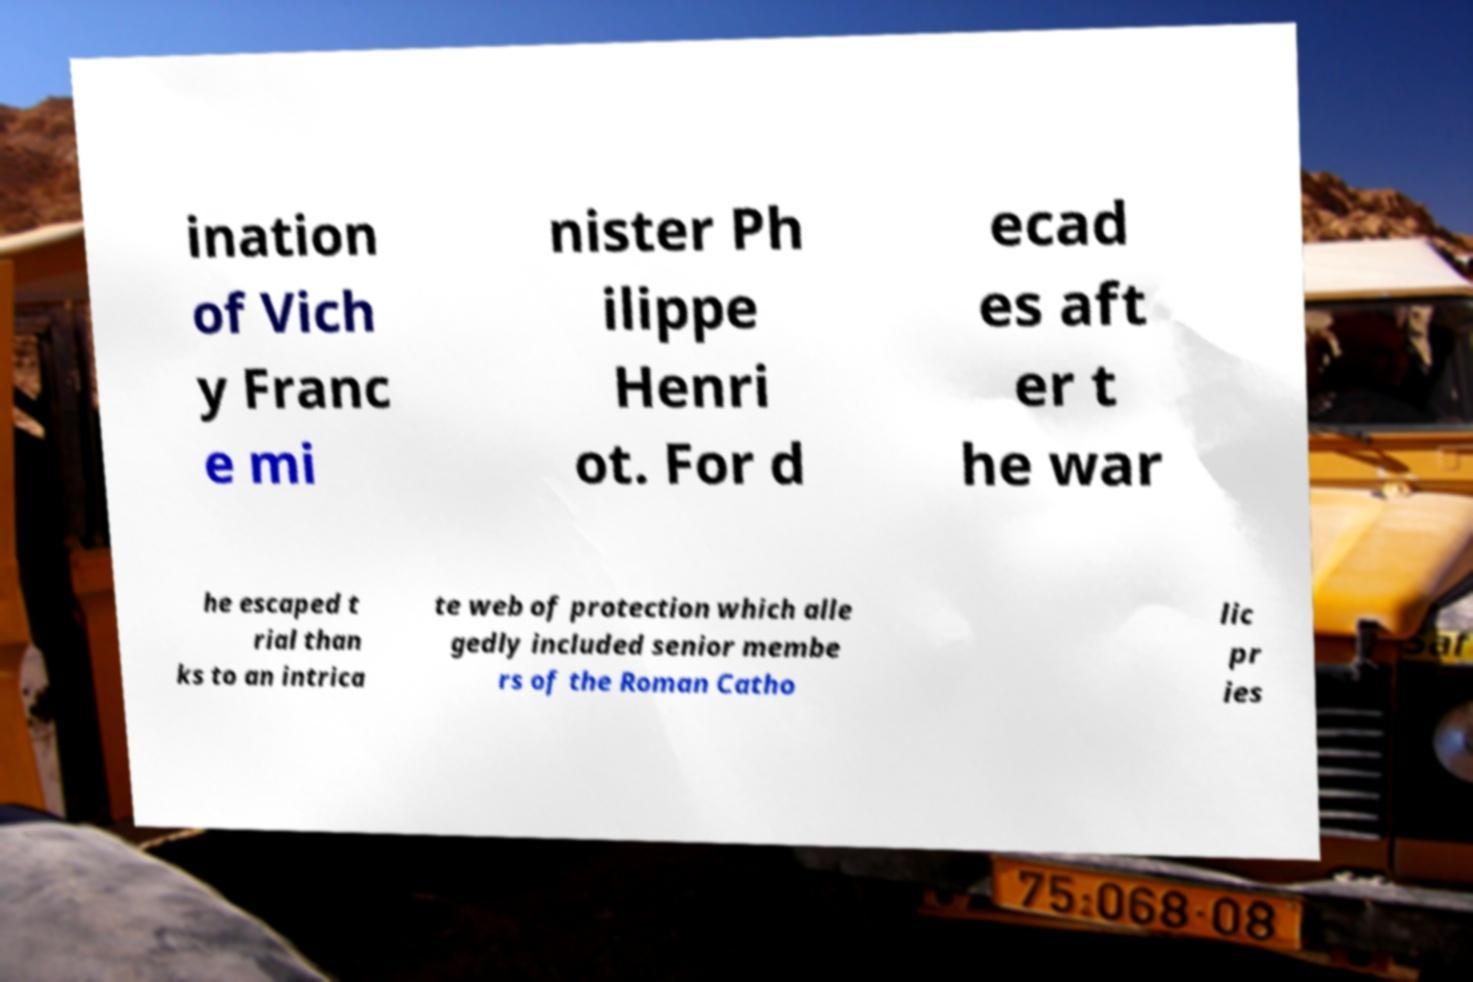Could you extract and type out the text from this image? ination of Vich y Franc e mi nister Ph ilippe Henri ot. For d ecad es aft er t he war he escaped t rial than ks to an intrica te web of protection which alle gedly included senior membe rs of the Roman Catho lic pr ies 